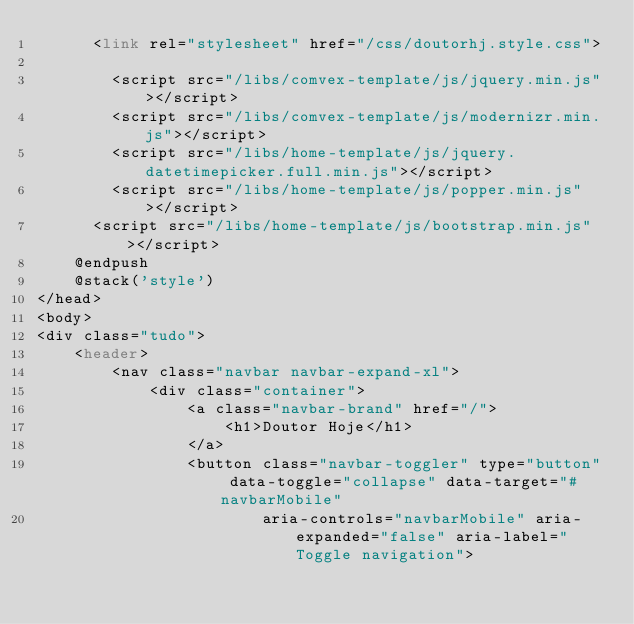Convert code to text. <code><loc_0><loc_0><loc_500><loc_500><_PHP_>    	<link rel="stylesheet" href="/css/doutorhj.style.css">
        
        <script src="/libs/comvex-template/js/jquery.min.js"></script>
        <script src="/libs/comvex-template/js/modernizr.min.js"></script>
        <script src="/libs/home-template/js/jquery.datetimepicker.full.min.js"></script>
        <script src="/libs/home-template/js/popper.min.js"></script>
    	<script src="/libs/home-template/js/bootstrap.min.js"></script>
    @endpush
    @stack('style')
</head>
<body>
<div class="tudo">
    <header>
        <nav class="navbar navbar-expand-xl">
            <div class="container">
                <a class="navbar-brand" href="/">
                    <h1>Doutor Hoje</h1>
                </a>
                <button class="navbar-toggler" type="button" data-toggle="collapse" data-target="#navbarMobile"
                        aria-controls="navbarMobile" aria-expanded="false" aria-label="Toggle navigation"></code> 